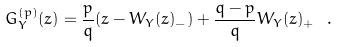<formula> <loc_0><loc_0><loc_500><loc_500>G _ { Y } ^ { ( p ) } ( z ) = \frac { p } { q } ( z - W _ { Y } ( z ) _ { - } ) + \frac { q - p } { q } W _ { Y } ( z ) _ { + } \ .</formula> 